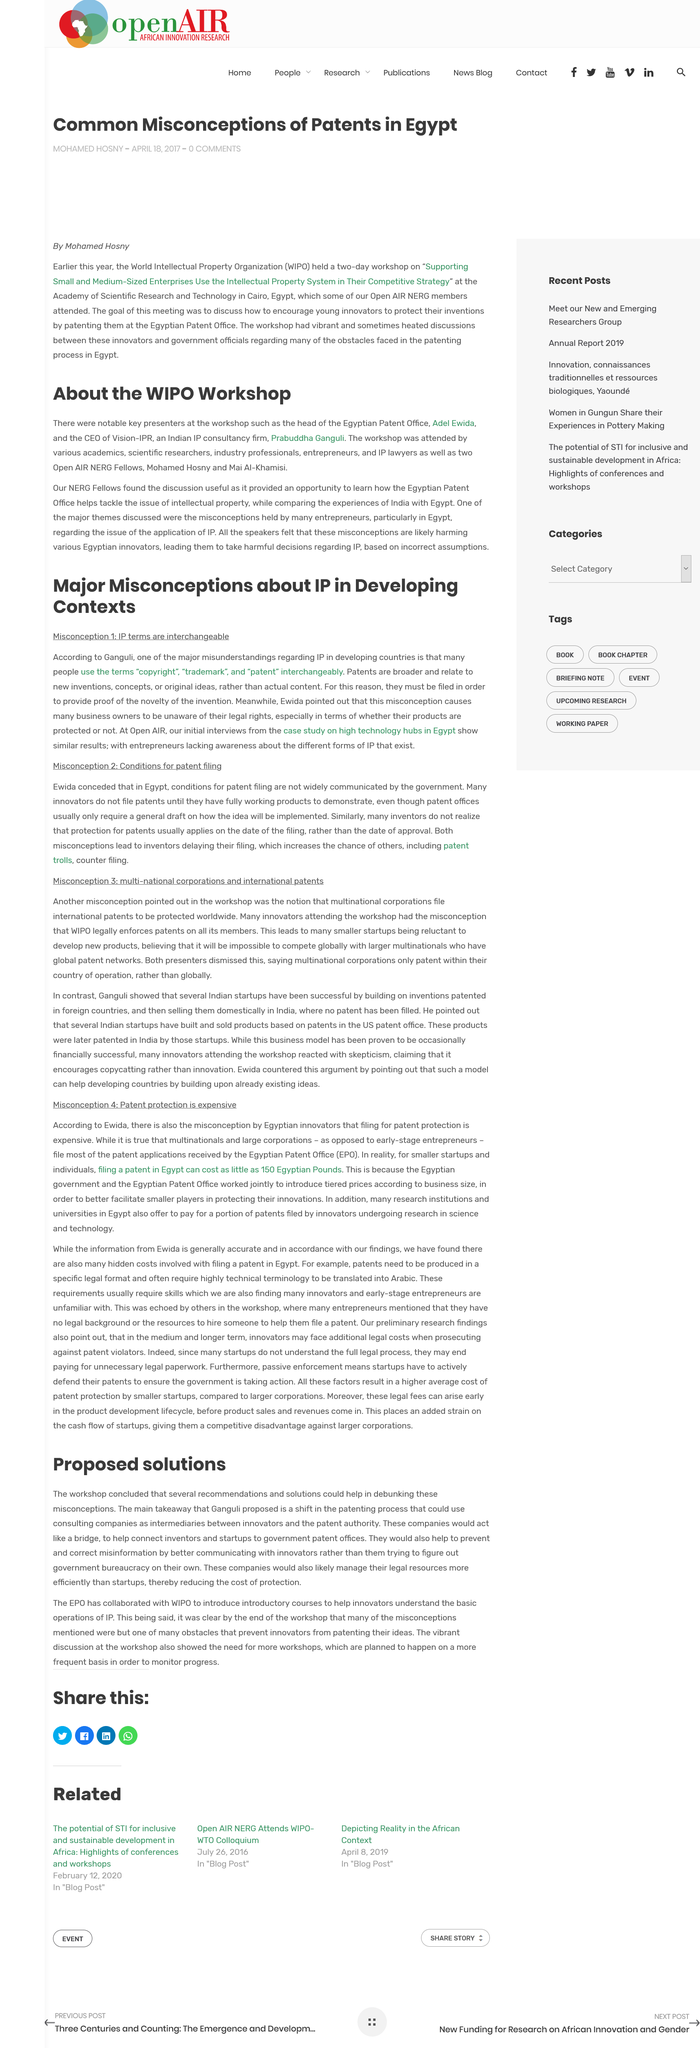Mention a couple of crucial points in this snapshot. The article suggests that intermediary consulting companies may reduce the cost of protection for startups by more efficiently managing their legal resources, making it a more cost-effective solution for startups looking to protect their intellectual property. One common misconception about intellectual property in developing countries is the interchangeability of terms such as copyright, trademark, and patent. The two-day workshop was held at the Academy of Scientific Research and Technology in Cairo, Egypt. Adel Ewida is the head of the Egyptian Patent Office. The misconception surrounding intellectual property in developing countries leads to widespread ignorance among business owners about their legal rights, causing significant harm to their ability to protect and leverage their creations and innovations. 